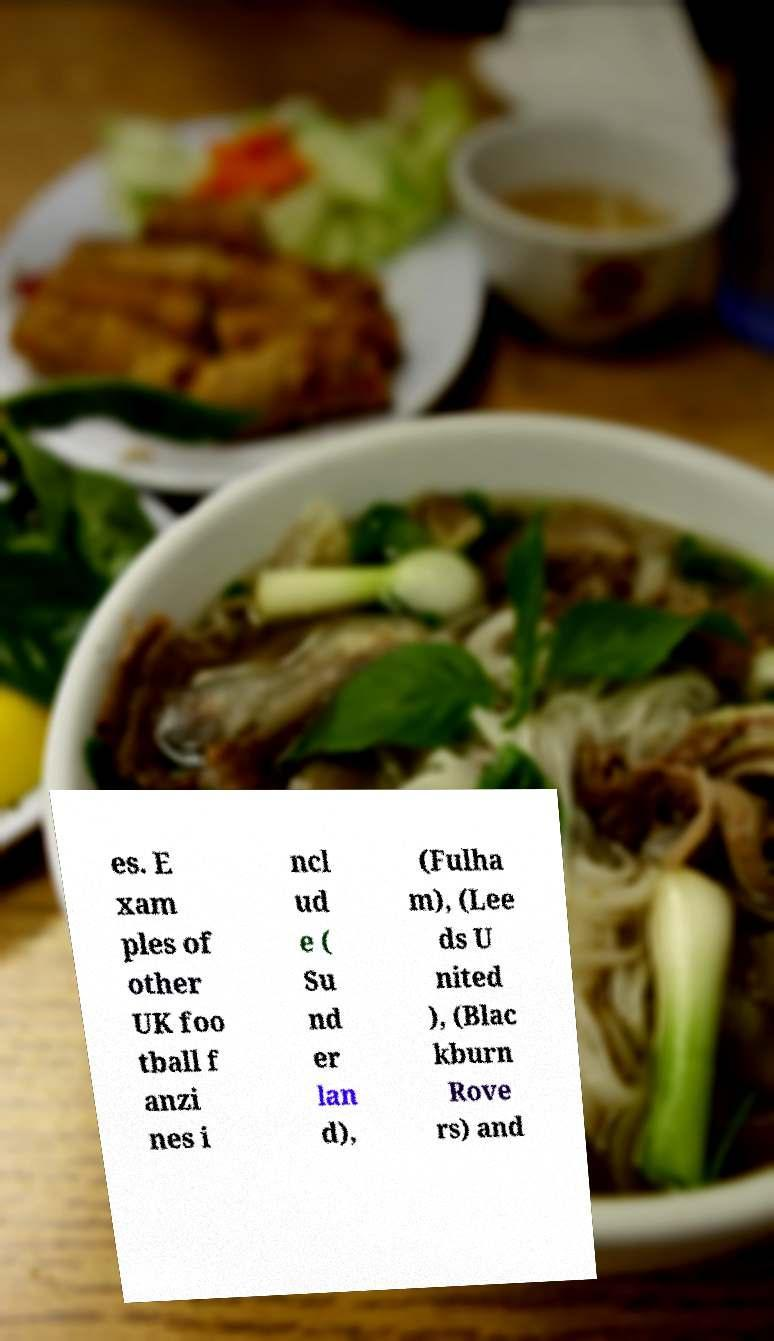Can you read and provide the text displayed in the image?This photo seems to have some interesting text. Can you extract and type it out for me? es. E xam ples of other UK foo tball f anzi nes i ncl ud e ( Su nd er lan d), (Fulha m), (Lee ds U nited ), (Blac kburn Rove rs) and 